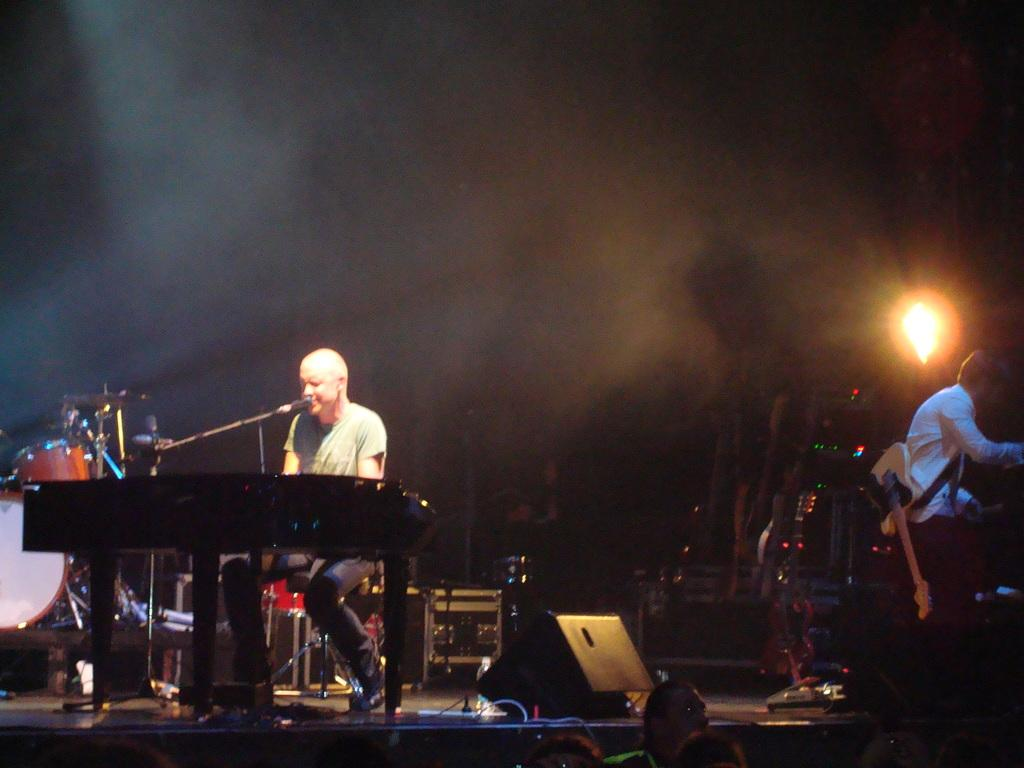What is the man in the image doing? The man is sitting and playing a piano in the image. What else is the man doing while playing the piano? The man is singing a song in the image and using a microphone while singing. What can be seen in the background of the image? There is a speaker and another man sitting in the background of the image. What is the second man doing in the image? The second man is playing drums in the image. What type of mitten is the man wearing while playing the piano? There is no mitten visible in the image; the man is not wearing any gloves or mittens. What kind of rock is the man using to play the piano? The man is not using a rock to play the piano; he is using his hands to play the keys. 